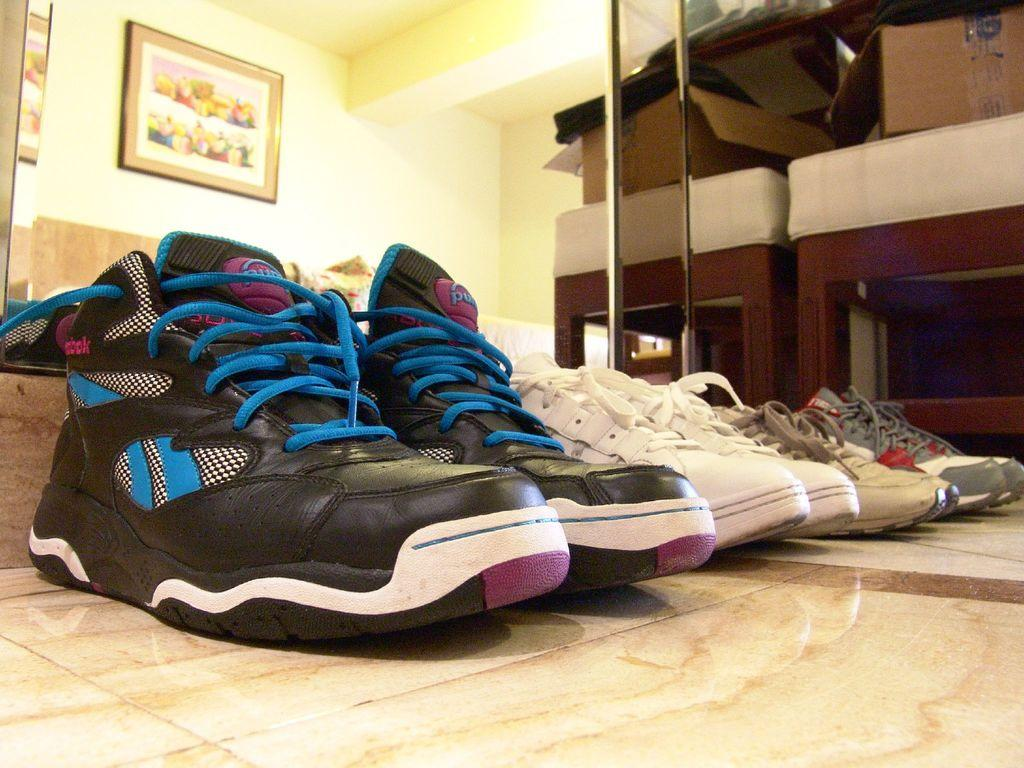What can you describe the object that is in the front of the image? There are shoes in the front of the image. What can be seen on the wall in the background of the image? There is a frame on the wall in the background of the image. Where is the brown object located in the image? The brown object is on a stool in the right side of the image. Is the queen wearing the underwear in the image? There is no mention of a queen or underwear in the image, so we cannot answer this question. 